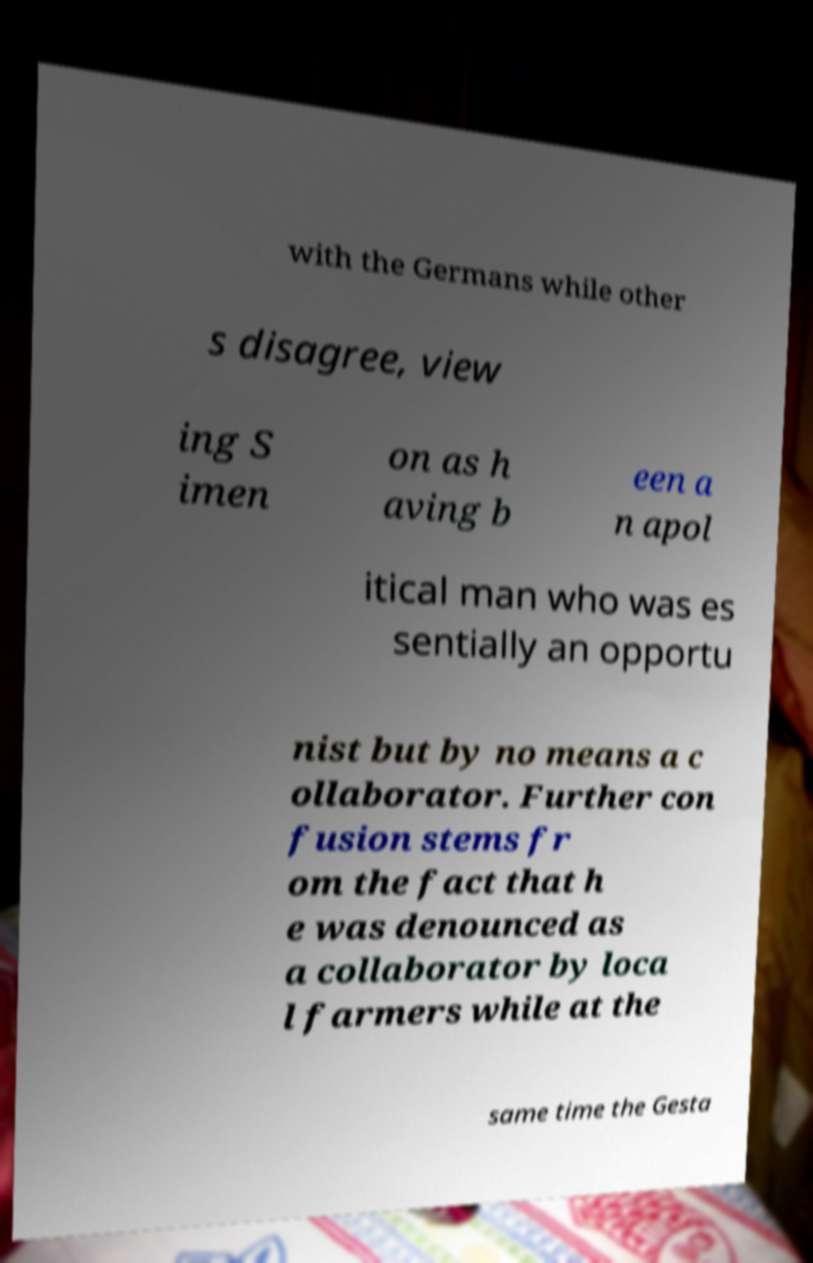Could you assist in decoding the text presented in this image and type it out clearly? with the Germans while other s disagree, view ing S imen on as h aving b een a n apol itical man who was es sentially an opportu nist but by no means a c ollaborator. Further con fusion stems fr om the fact that h e was denounced as a collaborator by loca l farmers while at the same time the Gesta 